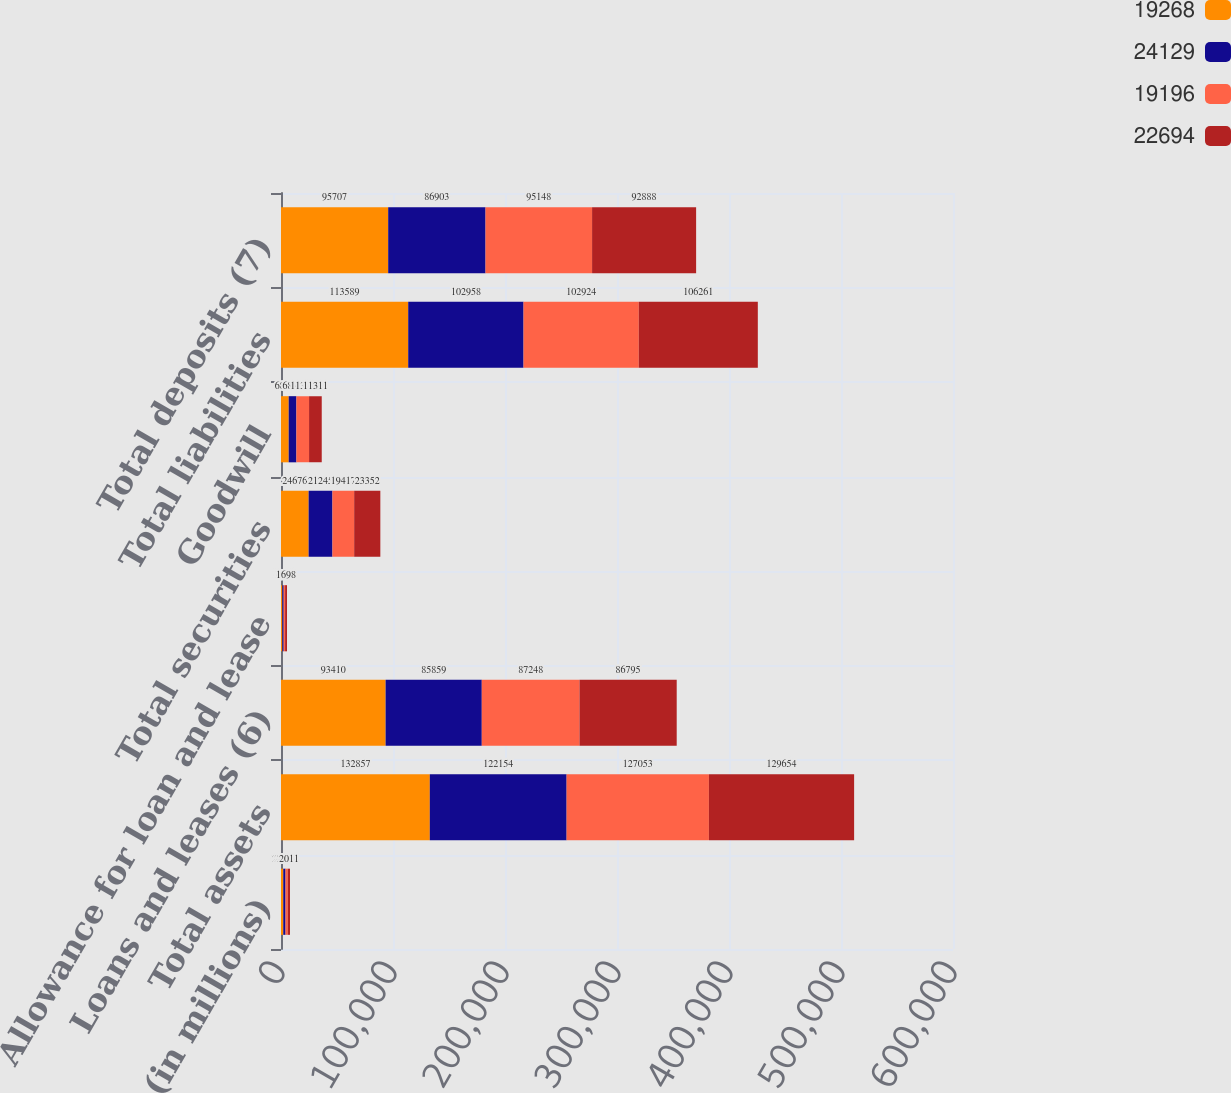Convert chart. <chart><loc_0><loc_0><loc_500><loc_500><stacked_bar_chart><ecel><fcel>(in millions)<fcel>Total assets<fcel>Loans and leases (6)<fcel>Allowance for loan and lease<fcel>Total securities<fcel>Goodwill<fcel>Total liabilities<fcel>Total deposits (7)<nl><fcel>19268<fcel>2014<fcel>132857<fcel>93410<fcel>1195<fcel>24676<fcel>6876<fcel>113589<fcel>95707<nl><fcel>24129<fcel>2013<fcel>122154<fcel>85859<fcel>1221<fcel>21245<fcel>6876<fcel>102958<fcel>86903<nl><fcel>19196<fcel>2012<fcel>127053<fcel>87248<fcel>1255<fcel>19417<fcel>11311<fcel>102924<fcel>95148<nl><fcel>22694<fcel>2011<fcel>129654<fcel>86795<fcel>1698<fcel>23352<fcel>11311<fcel>106261<fcel>92888<nl></chart> 